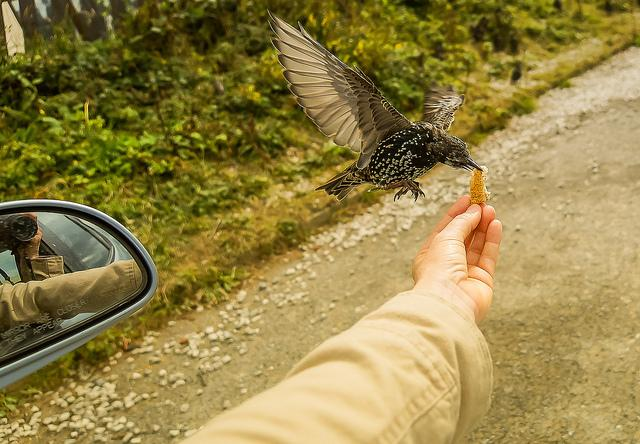What is the man doing to the bird? Please explain your reasoning. feeding it. He is holding a piece of food out 